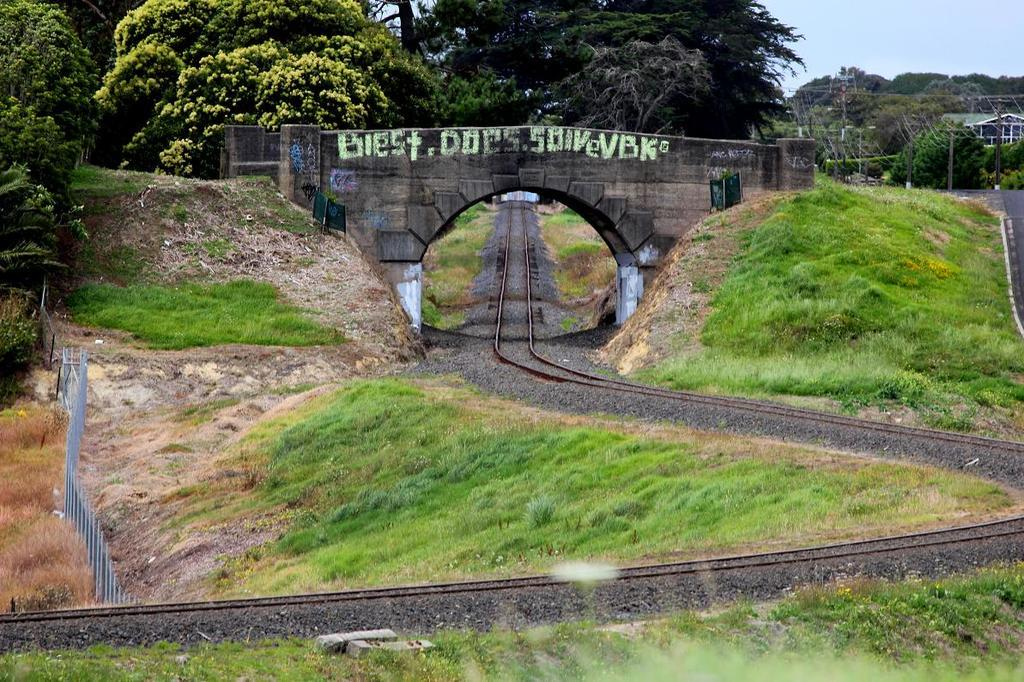<image>
Describe the image concisely. Train tracks run under a stone bridge which has grafitti on it that says Biest.Does.SolveVBK, 